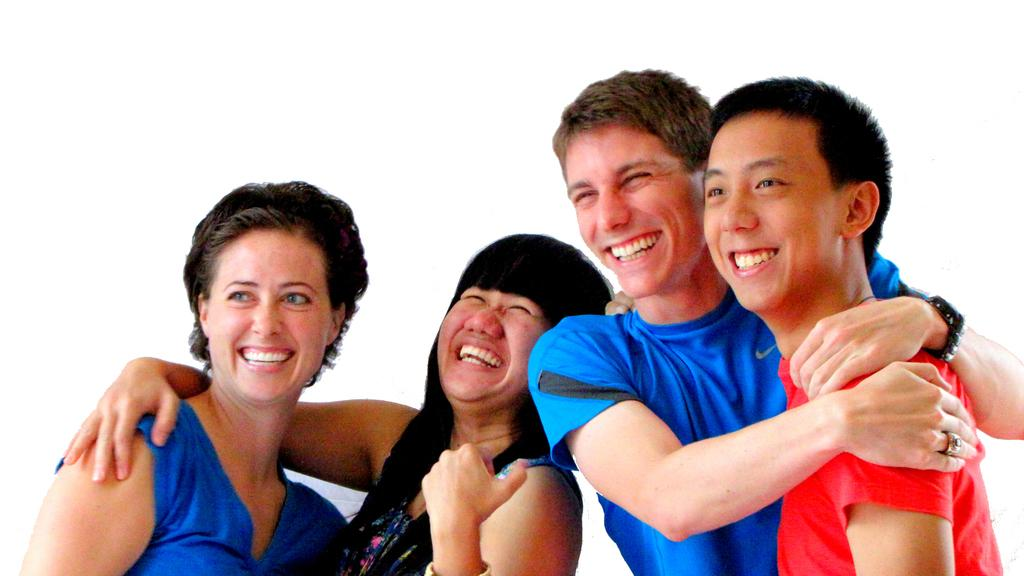How many people are present in the image? There are four people in the image. What expressions do the people have in the image? The four people are smiling. What color is the background of the image? The background of the image is white. How many pockets can be seen on the people in the image? There is no information about pockets on the people in the image, so it cannot be determined. What type of finger is visible in the image? There is no specific finger mentioned or visible in the image. 